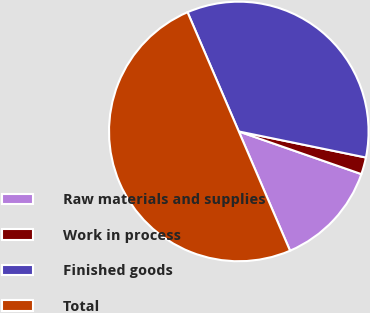Convert chart to OTSL. <chart><loc_0><loc_0><loc_500><loc_500><pie_chart><fcel>Raw materials and supplies<fcel>Work in process<fcel>Finished goods<fcel>Total<nl><fcel>13.21%<fcel>2.11%<fcel>34.68%<fcel>50.0%<nl></chart> 